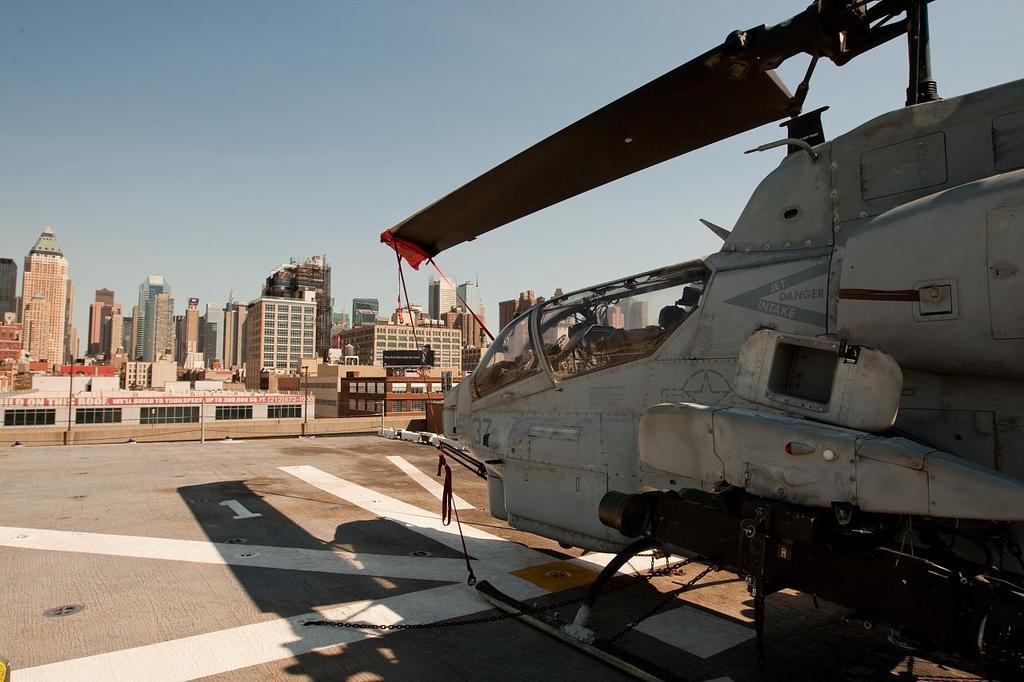How would you summarize this image in a sentence or two? In this image we can see a helicopter on the land. On the backside we can see some buildings and the sky. 